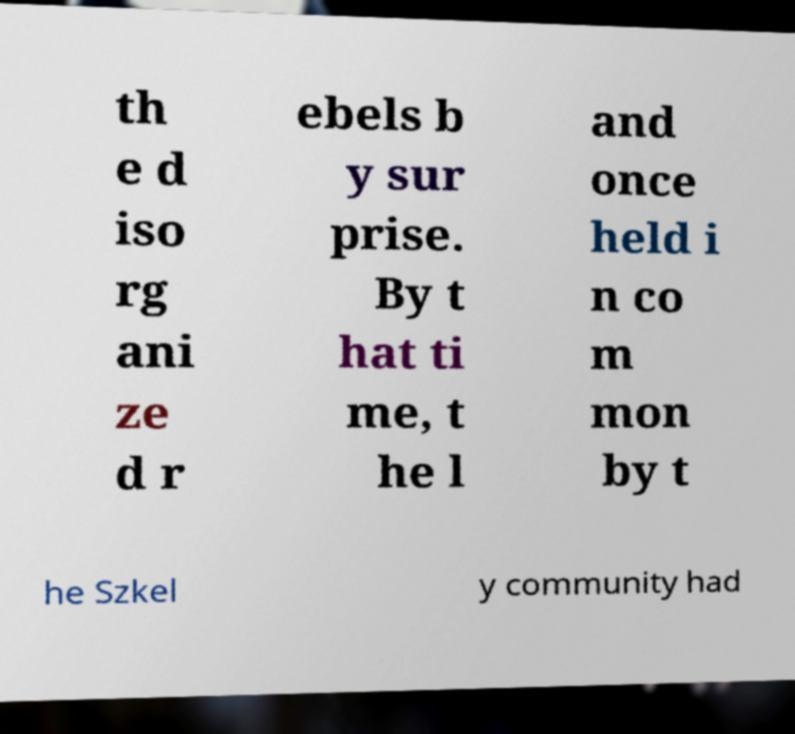I need the written content from this picture converted into text. Can you do that? th e d iso rg ani ze d r ebels b y sur prise. By t hat ti me, t he l and once held i n co m mon by t he Szkel y community had 